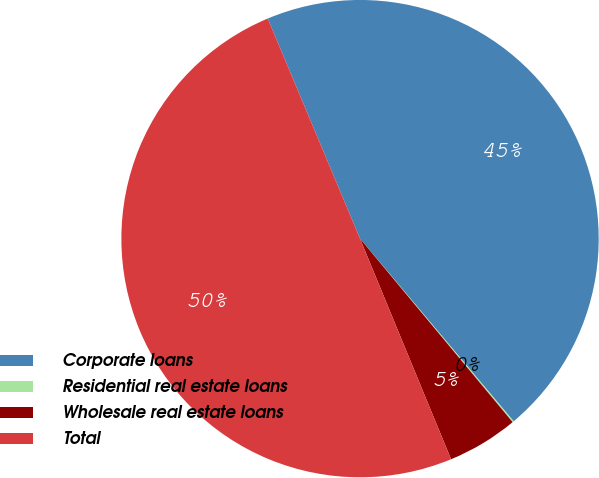Convert chart. <chart><loc_0><loc_0><loc_500><loc_500><pie_chart><fcel>Corporate loans<fcel>Residential real estate loans<fcel>Wholesale real estate loans<fcel>Total<nl><fcel>45.19%<fcel>0.09%<fcel>4.81%<fcel>49.91%<nl></chart> 